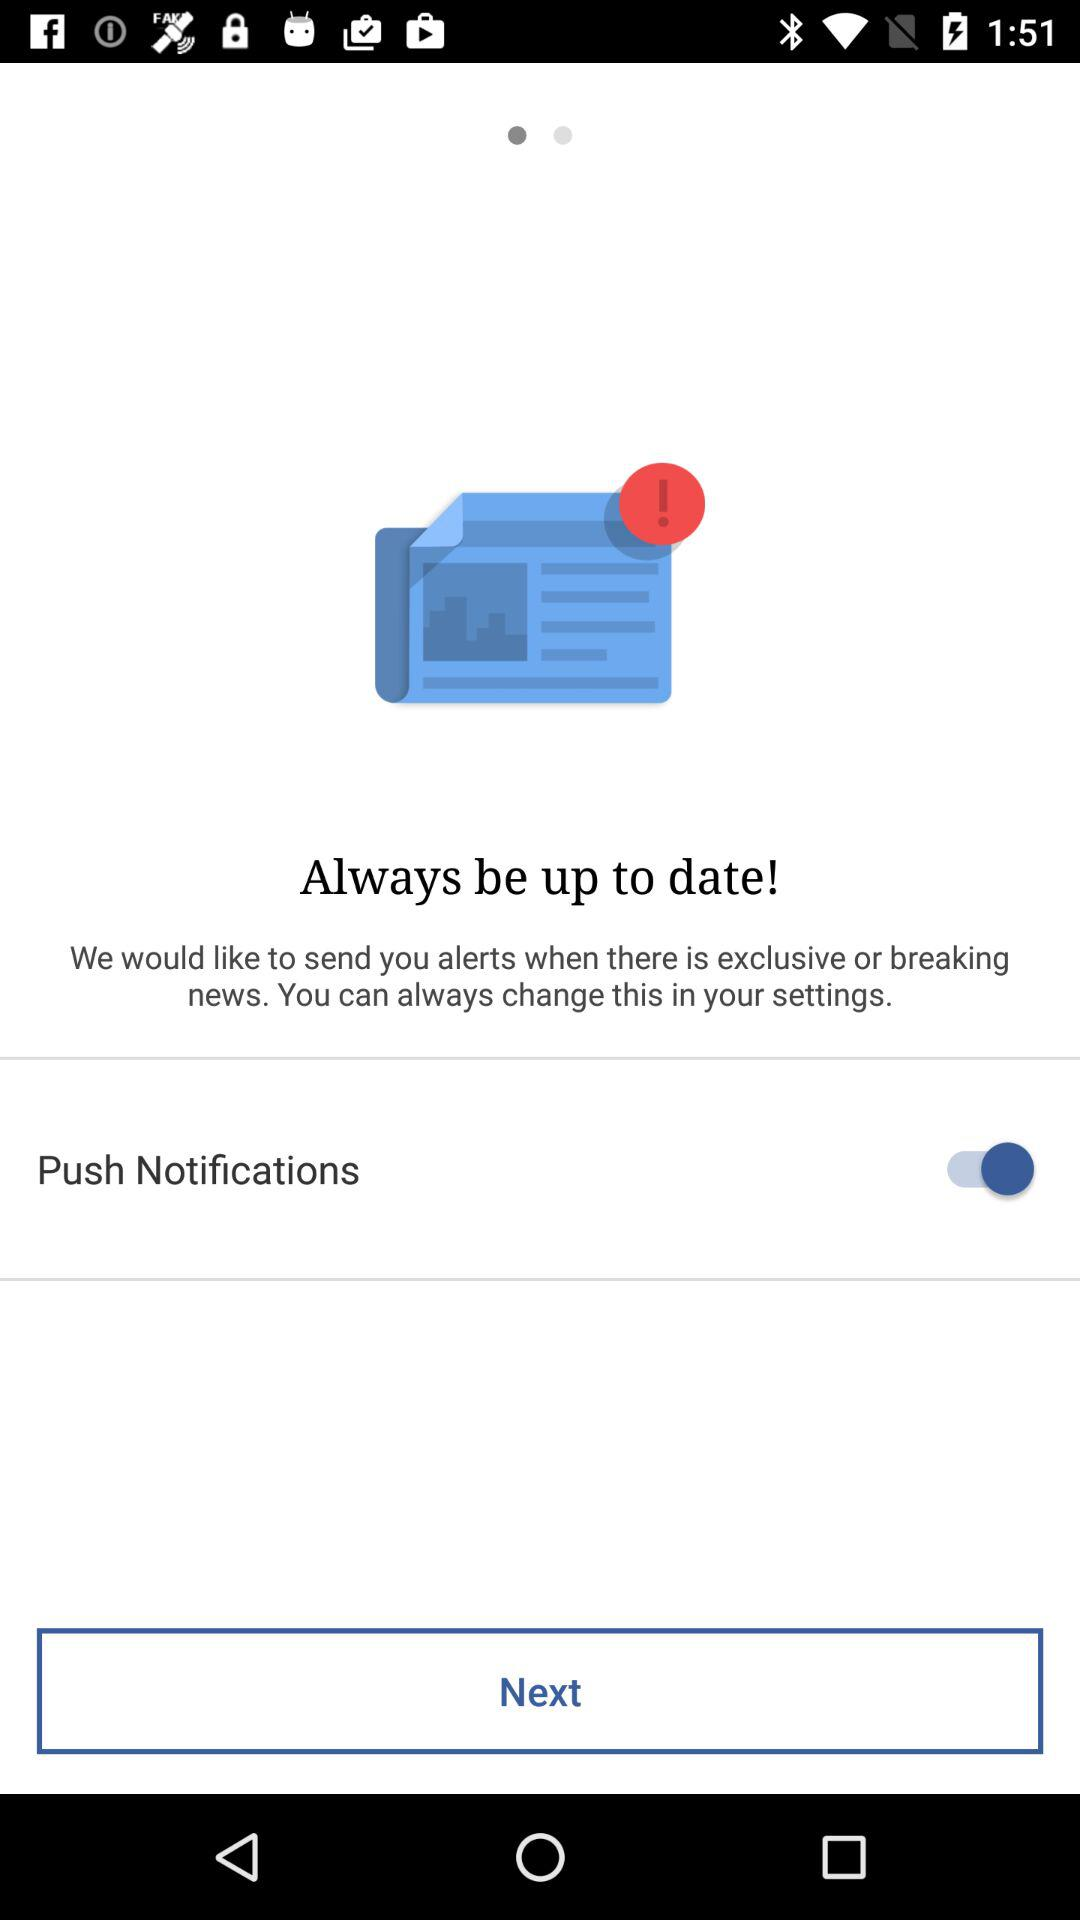What is the status of "Push Notifications"? The status is "on". 